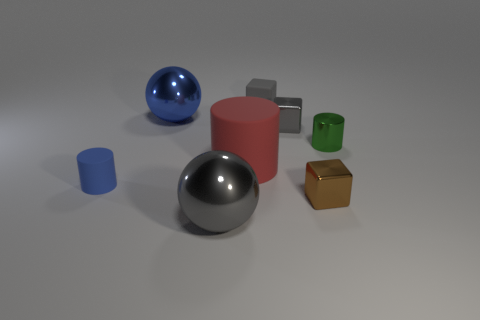Subtract all small cylinders. How many cylinders are left? 1 Add 2 blue things. How many objects exist? 10 Subtract all blue cylinders. How many cylinders are left? 2 Subtract all yellow balls. How many gray cubes are left? 2 Subtract all spheres. How many objects are left? 6 Subtract 2 cylinders. How many cylinders are left? 1 Subtract all small blue rubber cylinders. Subtract all green metal cubes. How many objects are left? 7 Add 7 small gray rubber blocks. How many small gray rubber blocks are left? 8 Add 1 large matte cylinders. How many large matte cylinders exist? 2 Subtract 0 red balls. How many objects are left? 8 